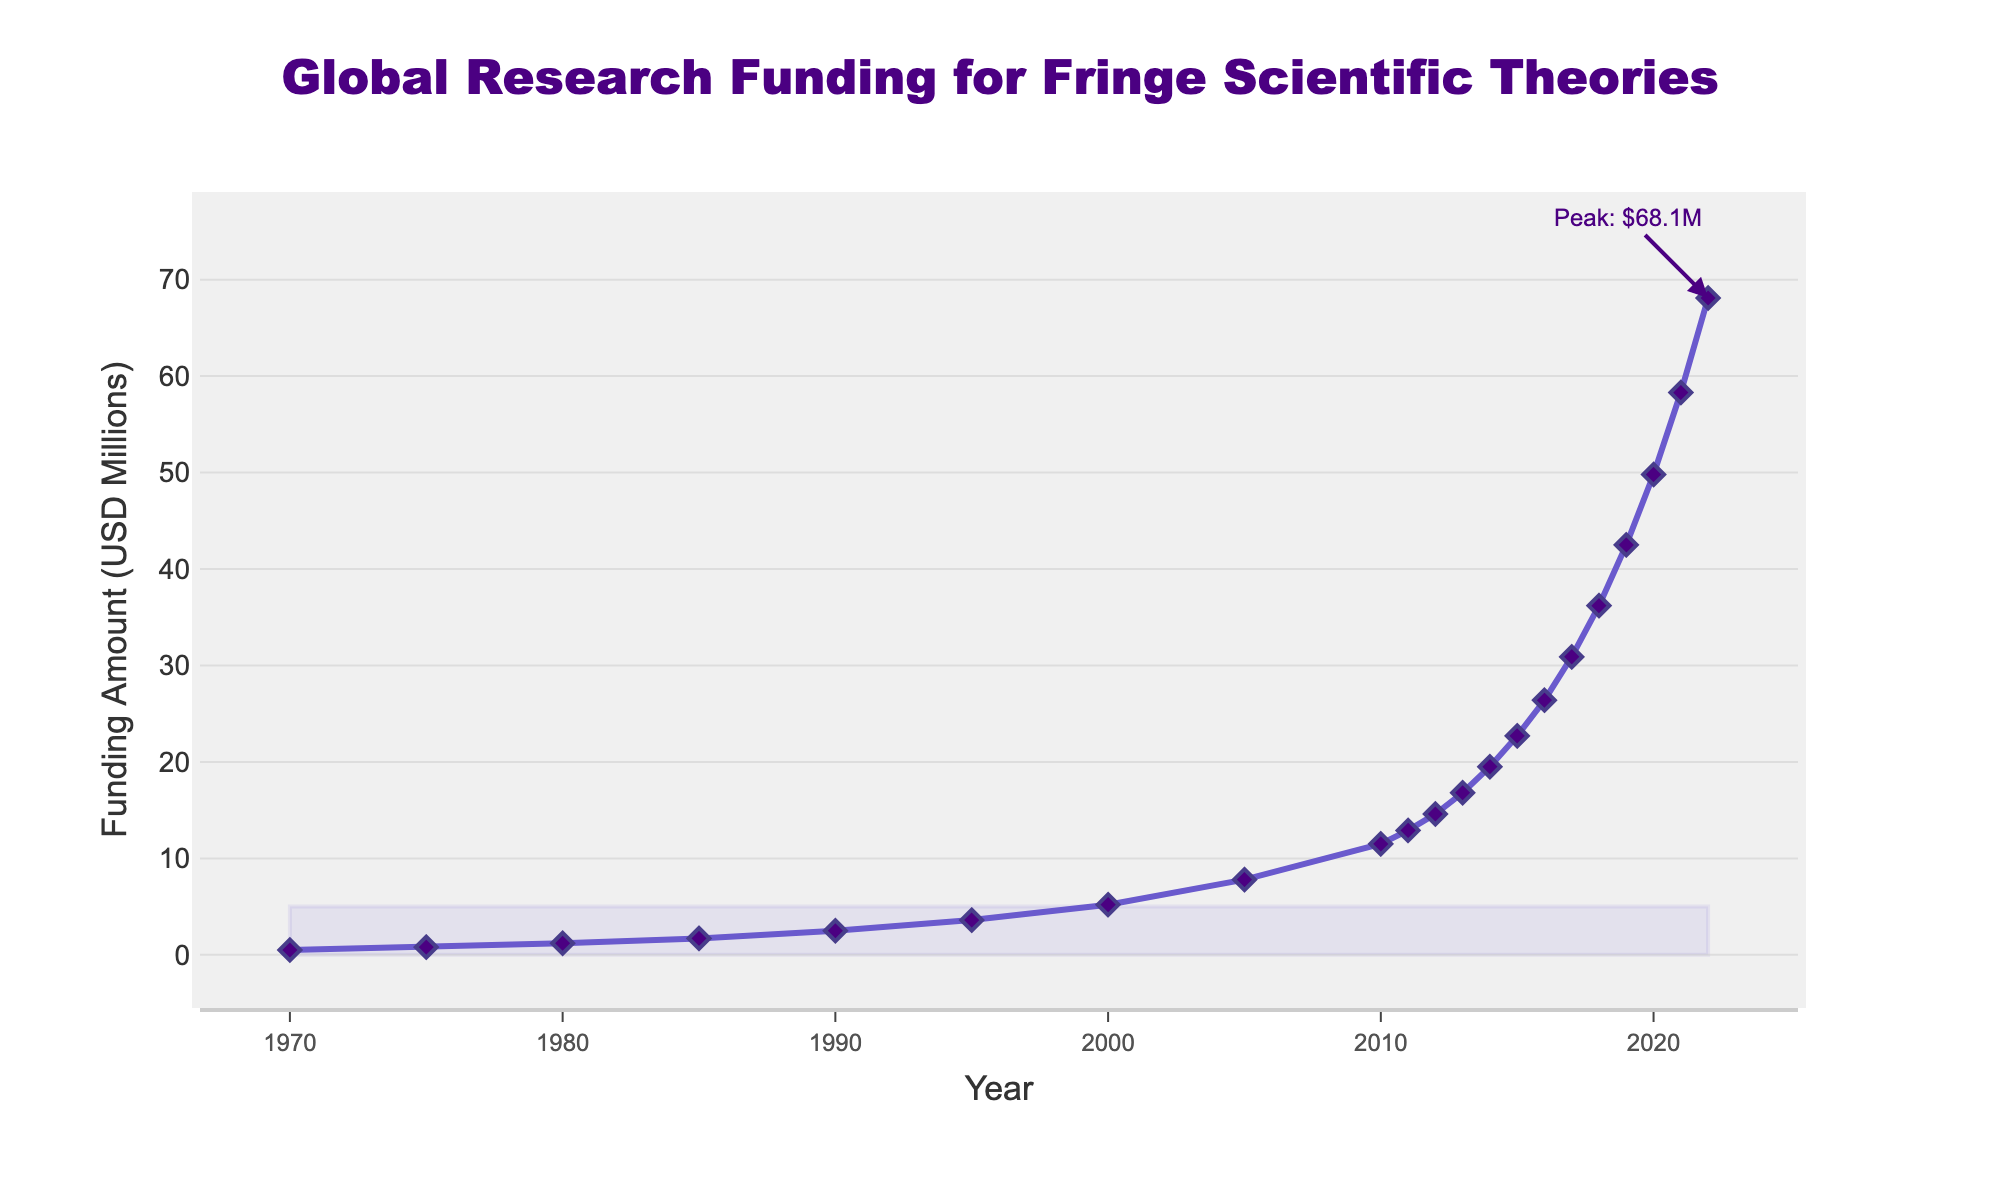What is the general trend of global research funding for fringe scientific theories from 1970 to 2022? The overall pattern shows that funding has been increasing steadily. Initially, the growth is gradual, but it becomes more pronounced after 2005, indicating an accelerated increase in funding amounts.
Answer: Increasing How much did the funding increase from 2010 to 2022? The funding amount in 2010 was $11.5 million, and in 2022 it was $68.1 million. The increase in funding is calculated by subtracting the 2010 value from the 2022 value: $68.1 million - $11.5 million = $56.6 million.
Answer: $56.6 million Which year saw the largest annual increase in funding between consecutive years? To find the largest annual increase, we need to look at the differences between consecutive years. Between 2021 and 2022, the funding increased from $58.3 million to $68.1 million, which is an increase of $9.8 million, the highest among all year pairs.
Answer: 2022 How many years did it take for the funding to double from the level it was in 2000? The funding amount in 2000 was $5.2 million. Doubling this value gives us $10.4 million. The funding crosses $10.4 million in 2010, where it is $11.5 million. Hence, it took 10 years.
Answer: 10 years How does the funding amount in 1980 compare to the funding amount in 1990? In 1980, the funding amount was $1.2 million, whereas in 1990, it was $2.5 million. By comparing these two values, we can see that the funding more than doubled in that decade.
Answer: It more than doubled What is the difference between the highest and the lowest recorded funding amounts in the dataset? The highest funding amount recorded is $68.1 million in 2022, and the lowest is $0.5 million in 1970. The difference is calculated as $68.1 million - $0.5 million = $67.6 million.
Answer: $67.6 million What can be inferred about the trend of funding between 2005 and 2010? From 2005 to 2010, the funding increased from $7.8 million to $11.5 million. This period saw a relatively steady rise compared to earlier phases but was less steep compared to the years following 2010.
Answer: Steady rise What is the average annual increase in funding between 2015 and 2020? In 2015, the funding amount was $22.7 million, and in 2020 it was $49.8 million. The increase over these 5 years is $49.8 million - $22.7 million = $27.1 million. The average annual increase is then $27.1 million / 5 = $5.42 million per year.
Answer: $5.42 million per year Which time period experienced nearly a tripling of funding? The time period between 2010 and 2020 saw funding rise from $11.5 million to $49.8 million. Checking the numbers: $11.5 million * 3 = $34.5 million. Since $49.8 million is way above $34.5 million, it indicates the funding nearly tripled.
Answer: 2010 to 2020 